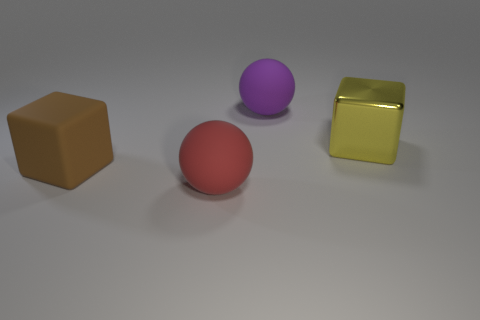What shape is the big matte thing on the right side of the large red object?
Make the answer very short. Sphere. How many small brown things are there?
Give a very brief answer. 0. There is a big block that is the same material as the big red ball; what is its color?
Your answer should be very brief. Brown. What number of small things are either brown rubber blocks or yellow metal balls?
Your response must be concise. 0. What number of matte things are right of the matte block?
Provide a succinct answer. 2. There is another rubber thing that is the same shape as the purple matte object; what is its color?
Make the answer very short. Red. How many shiny things are red things or big purple things?
Ensure brevity in your answer.  0. Are there any large red objects behind the large object left of the sphere that is in front of the purple sphere?
Provide a succinct answer. No. The metal object is what color?
Ensure brevity in your answer.  Yellow. Do the thing right of the large purple thing and the large purple object have the same shape?
Give a very brief answer. No. 